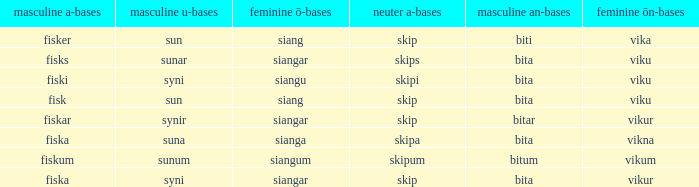What ending does siangu get for ön? Viku. 